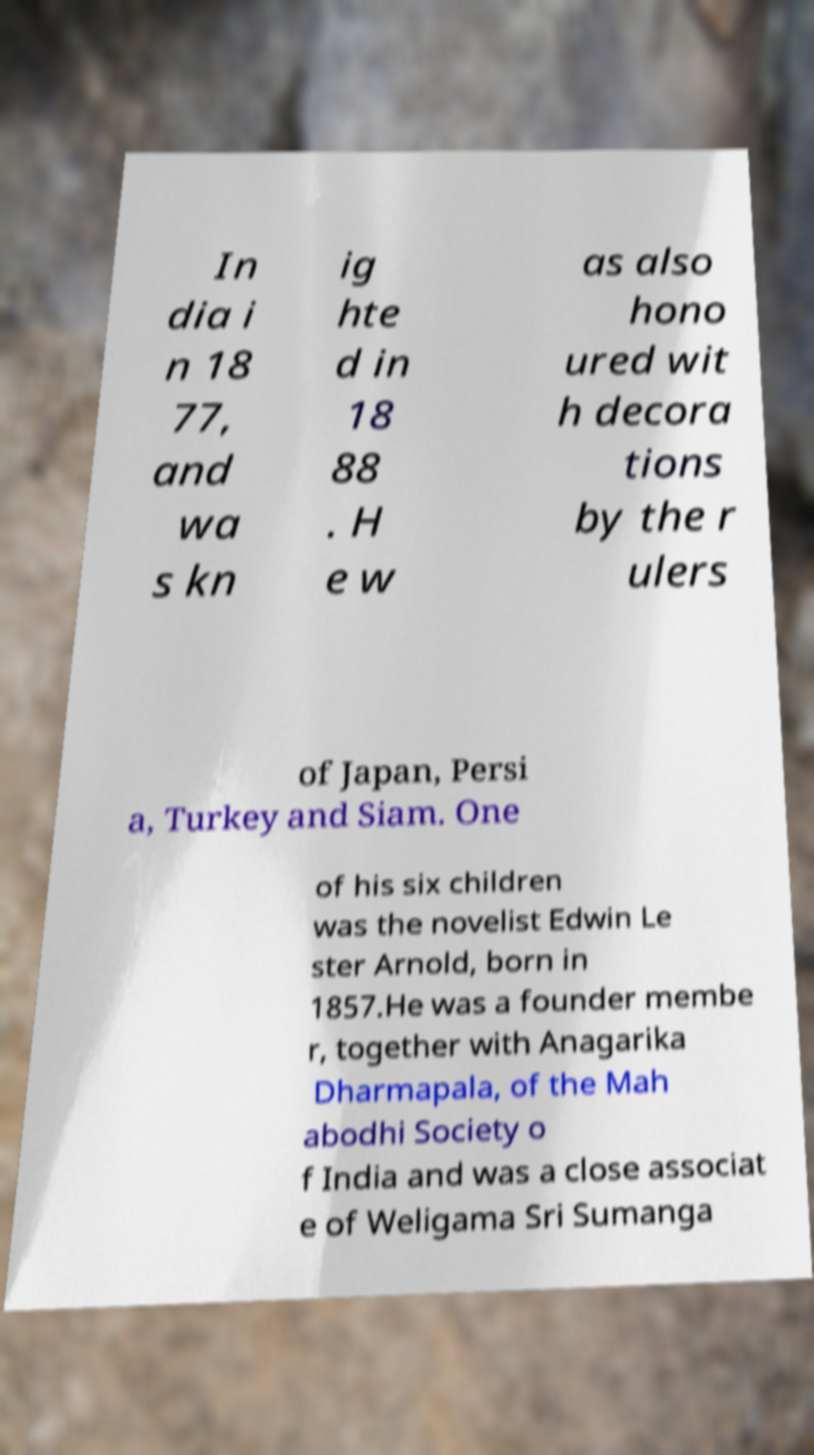Can you accurately transcribe the text from the provided image for me? In dia i n 18 77, and wa s kn ig hte d in 18 88 . H e w as also hono ured wit h decora tions by the r ulers of Japan, Persi a, Turkey and Siam. One of his six children was the novelist Edwin Le ster Arnold, born in 1857.He was a founder membe r, together with Anagarika Dharmapala, of the Mah abodhi Society o f India and was a close associat e of Weligama Sri Sumanga 